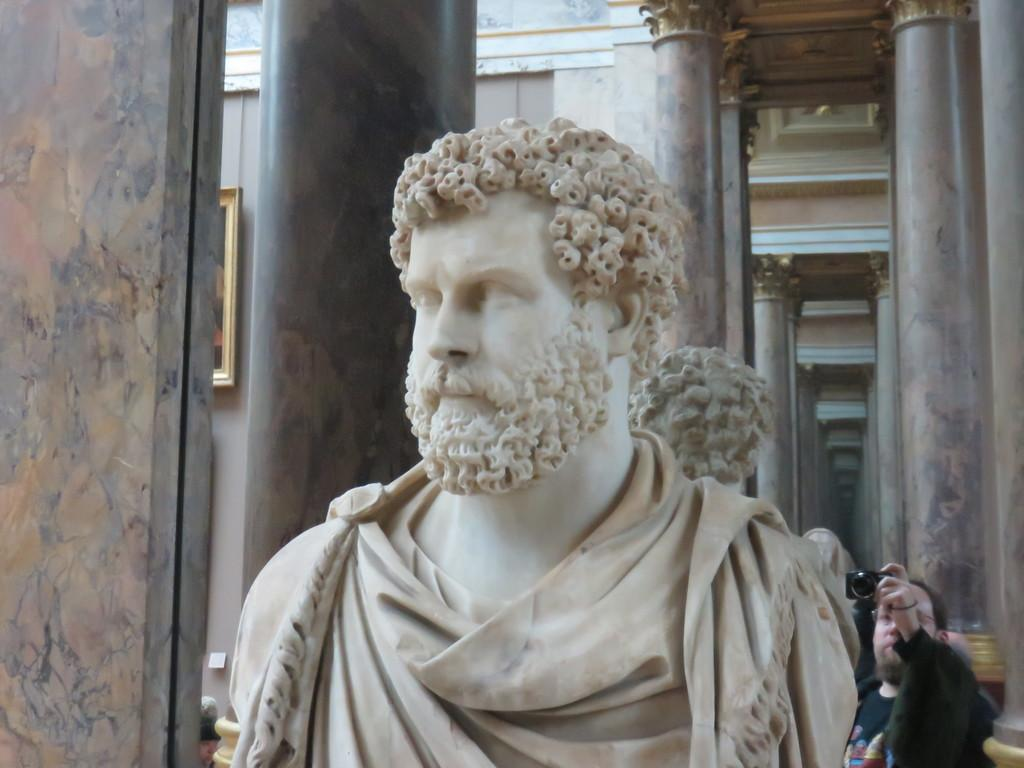What is the main subject in the image? There is a statue in the image. Can you describe the position of the statue? The statue is standing. What other object is present in the image? There is a mirror in the image. What can be seen in the mirror? The reflection of a person holding a camera is visible in the mirror. What type of tramp is visible in the image? There is no tramp present in the image. How does the light affect the appearance of the statue in the image? The provided facts do not mention any specific lighting conditions, so we cannot determine how the light affects the appearance of the statue in the image. 